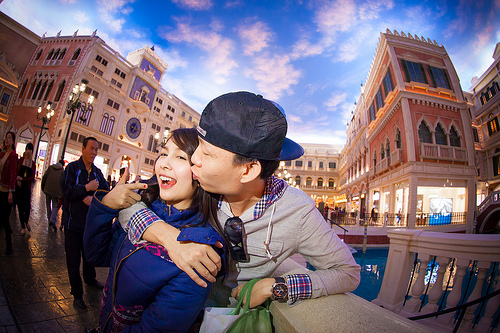<image>
Is the clock behind the lady? Yes. From this viewpoint, the clock is positioned behind the lady, with the lady partially or fully occluding the clock. 